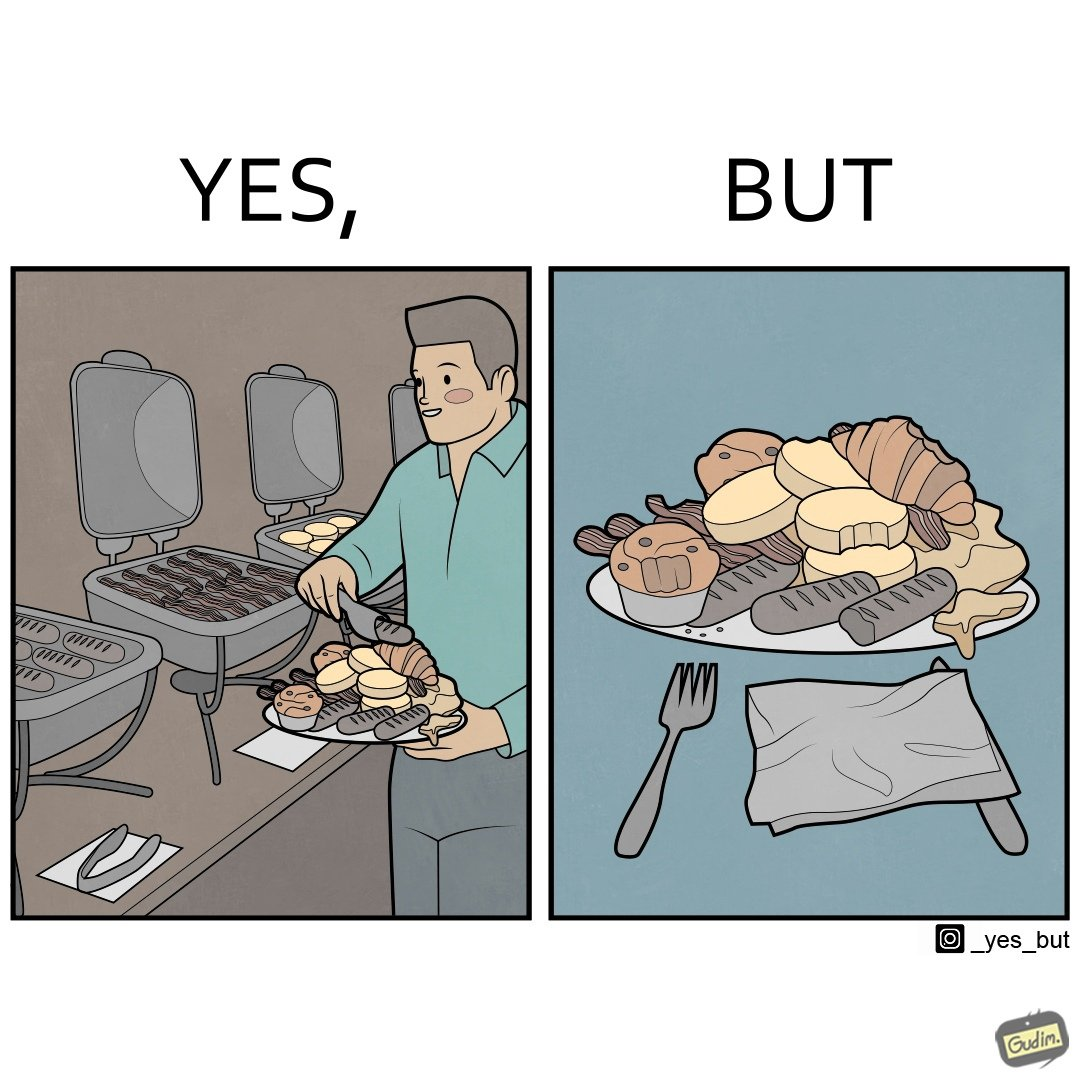What is shown in the left half versus the right half of this image? In the left part of the image: The image shows a man overfilling his plate with different kinds of food from a self serving station with various items placed on it. In the right part of the image: The image shows a plate full of food items. Most of the items seems untouched and few have been taken a bite from. 